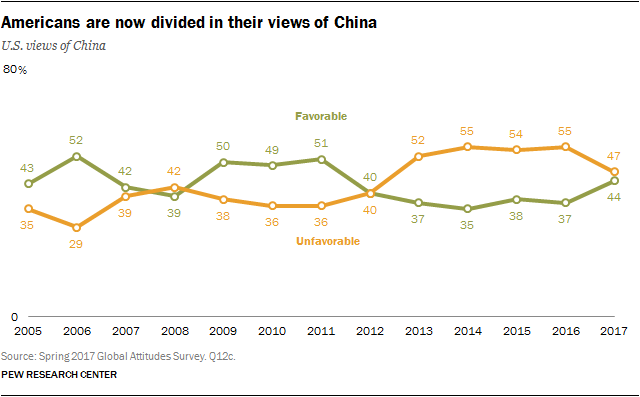Draw attention to some important aspects in this diagram. The greatest difference between the two sentiments across all years is 23... What is the only intercepting point of the two lines 40 and 40? 